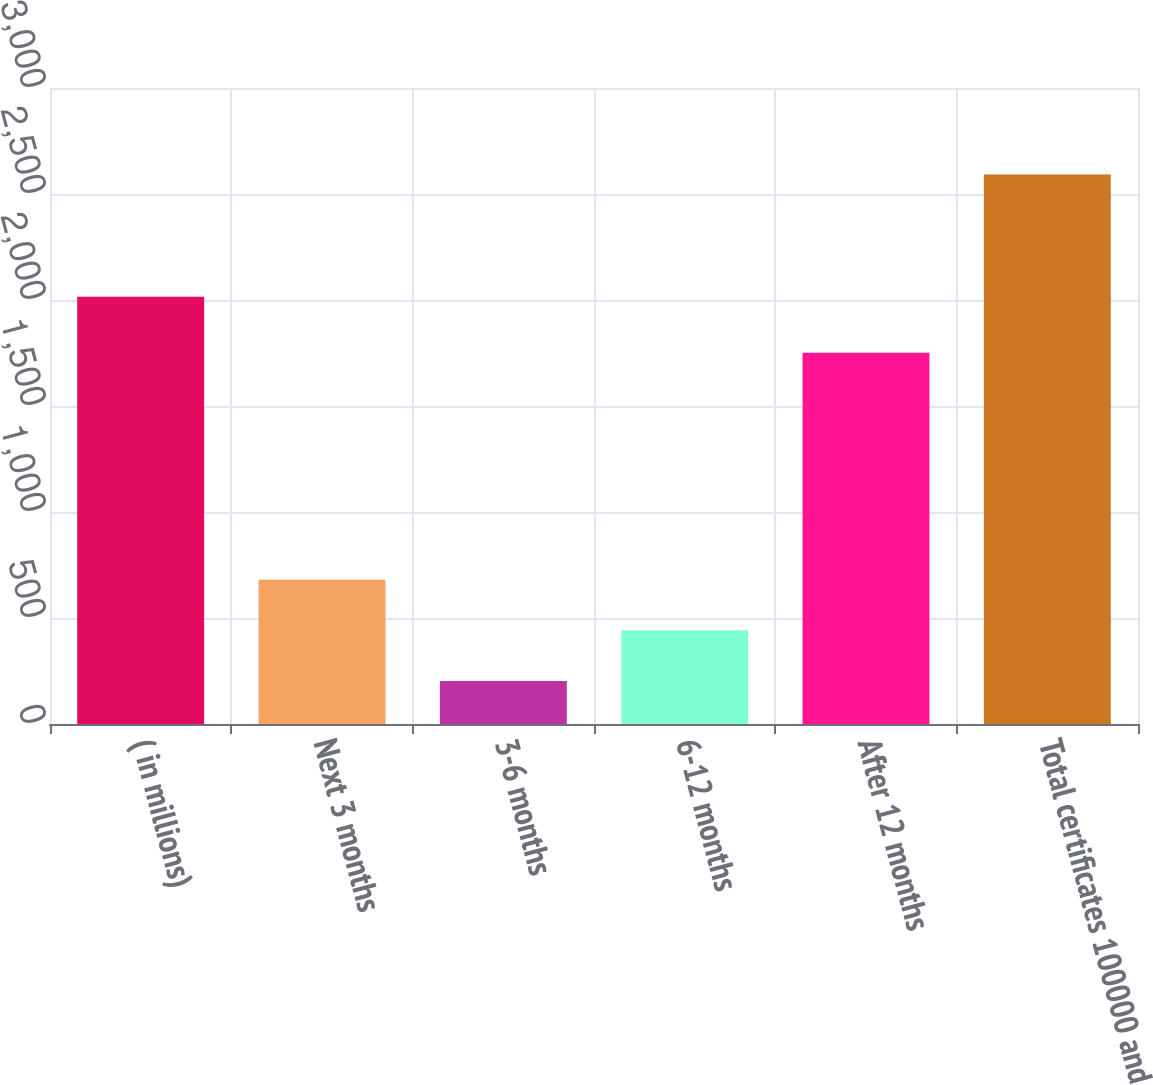<chart> <loc_0><loc_0><loc_500><loc_500><bar_chart><fcel>( in millions)<fcel>Next 3 months<fcel>3-6 months<fcel>6-12 months<fcel>After 12 months<fcel>Total certificates 100000 and<nl><fcel>2015<fcel>680.8<fcel>203<fcel>441.9<fcel>1751<fcel>2592<nl></chart> 